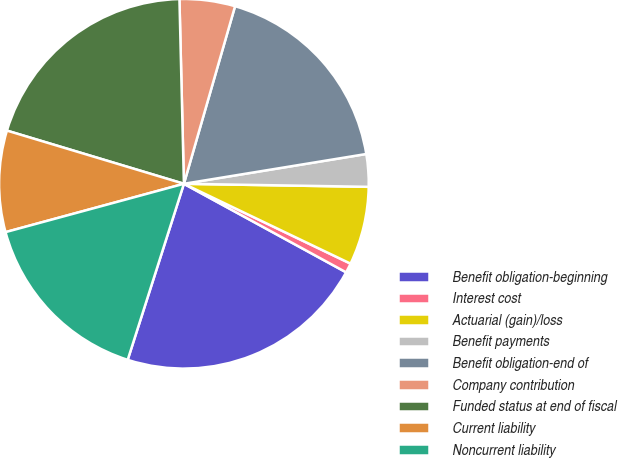<chart> <loc_0><loc_0><loc_500><loc_500><pie_chart><fcel>Benefit obligation-beginning<fcel>Interest cost<fcel>Actuarial (gain)/loss<fcel>Benefit payments<fcel>Benefit obligation-end of<fcel>Company contribution<fcel>Funded status at end of fiscal<fcel>Current liability<fcel>Noncurrent liability<nl><fcel>21.97%<fcel>0.84%<fcel>6.85%<fcel>2.84%<fcel>17.96%<fcel>4.85%<fcel>19.97%<fcel>8.86%<fcel>15.87%<nl></chart> 